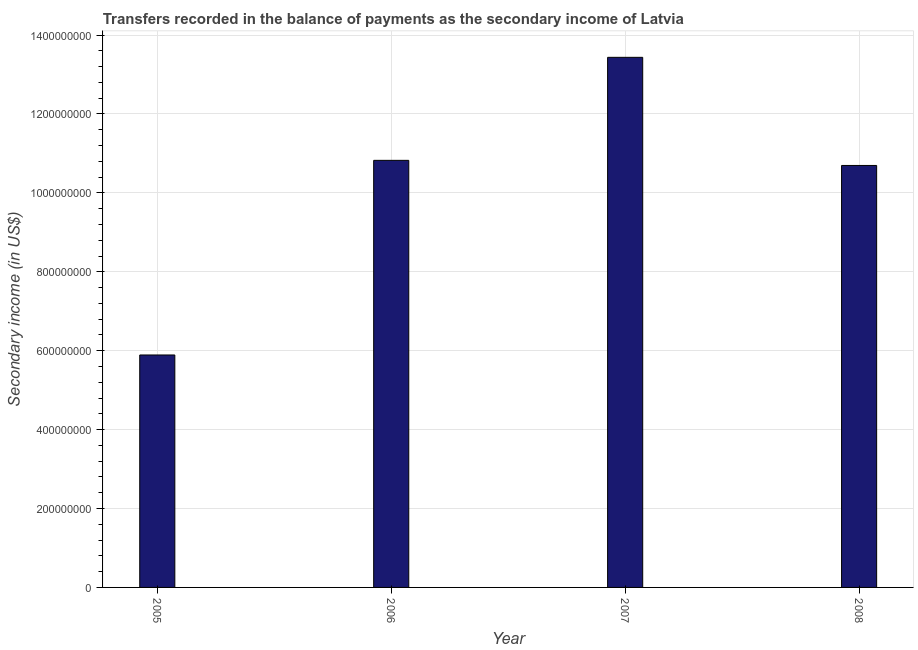Does the graph contain any zero values?
Give a very brief answer. No. What is the title of the graph?
Give a very brief answer. Transfers recorded in the balance of payments as the secondary income of Latvia. What is the label or title of the X-axis?
Your response must be concise. Year. What is the label or title of the Y-axis?
Offer a terse response. Secondary income (in US$). What is the amount of secondary income in 2005?
Offer a terse response. 5.89e+08. Across all years, what is the maximum amount of secondary income?
Make the answer very short. 1.34e+09. Across all years, what is the minimum amount of secondary income?
Your response must be concise. 5.89e+08. In which year was the amount of secondary income maximum?
Your answer should be very brief. 2007. What is the sum of the amount of secondary income?
Provide a short and direct response. 4.08e+09. What is the difference between the amount of secondary income in 2006 and 2008?
Keep it short and to the point. 1.29e+07. What is the average amount of secondary income per year?
Provide a short and direct response. 1.02e+09. What is the median amount of secondary income?
Give a very brief answer. 1.08e+09. In how many years, is the amount of secondary income greater than 960000000 US$?
Give a very brief answer. 3. What is the ratio of the amount of secondary income in 2005 to that in 2008?
Your answer should be compact. 0.55. Is the amount of secondary income in 2006 less than that in 2008?
Offer a terse response. No. Is the difference between the amount of secondary income in 2005 and 2008 greater than the difference between any two years?
Ensure brevity in your answer.  No. What is the difference between the highest and the second highest amount of secondary income?
Your response must be concise. 2.61e+08. What is the difference between the highest and the lowest amount of secondary income?
Give a very brief answer. 7.54e+08. In how many years, is the amount of secondary income greater than the average amount of secondary income taken over all years?
Your answer should be very brief. 3. How many years are there in the graph?
Offer a very short reply. 4. What is the difference between two consecutive major ticks on the Y-axis?
Provide a short and direct response. 2.00e+08. What is the Secondary income (in US$) in 2005?
Your answer should be compact. 5.89e+08. What is the Secondary income (in US$) in 2006?
Keep it short and to the point. 1.08e+09. What is the Secondary income (in US$) of 2007?
Make the answer very short. 1.34e+09. What is the Secondary income (in US$) in 2008?
Make the answer very short. 1.07e+09. What is the difference between the Secondary income (in US$) in 2005 and 2006?
Make the answer very short. -4.93e+08. What is the difference between the Secondary income (in US$) in 2005 and 2007?
Ensure brevity in your answer.  -7.54e+08. What is the difference between the Secondary income (in US$) in 2005 and 2008?
Make the answer very short. -4.80e+08. What is the difference between the Secondary income (in US$) in 2006 and 2007?
Keep it short and to the point. -2.61e+08. What is the difference between the Secondary income (in US$) in 2006 and 2008?
Offer a terse response. 1.29e+07. What is the difference between the Secondary income (in US$) in 2007 and 2008?
Keep it short and to the point. 2.74e+08. What is the ratio of the Secondary income (in US$) in 2005 to that in 2006?
Provide a short and direct response. 0.54. What is the ratio of the Secondary income (in US$) in 2005 to that in 2007?
Provide a succinct answer. 0.44. What is the ratio of the Secondary income (in US$) in 2005 to that in 2008?
Make the answer very short. 0.55. What is the ratio of the Secondary income (in US$) in 2006 to that in 2007?
Ensure brevity in your answer.  0.81. What is the ratio of the Secondary income (in US$) in 2007 to that in 2008?
Your response must be concise. 1.26. 